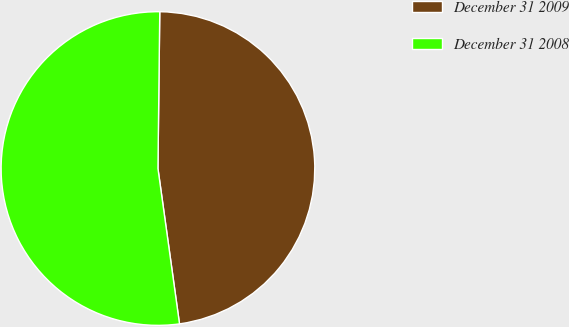<chart> <loc_0><loc_0><loc_500><loc_500><pie_chart><fcel>December 31 2009<fcel>December 31 2008<nl><fcel>47.62%<fcel>52.38%<nl></chart> 